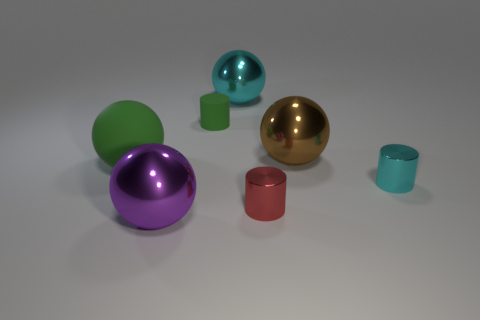What number of large spheres are the same color as the tiny matte cylinder? There is 1 large sphere that shares the same vivid turquoise color as the tiny matte cylinder. 